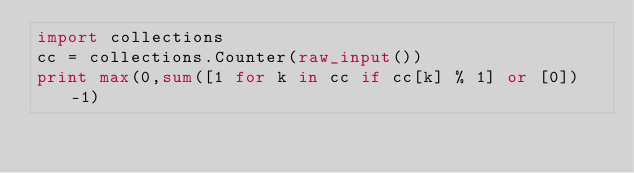Convert code to text. <code><loc_0><loc_0><loc_500><loc_500><_Python_>import collections
cc = collections.Counter(raw_input())
print max(0,sum([1 for k in cc if cc[k] % 1] or [0]) -1)</code> 